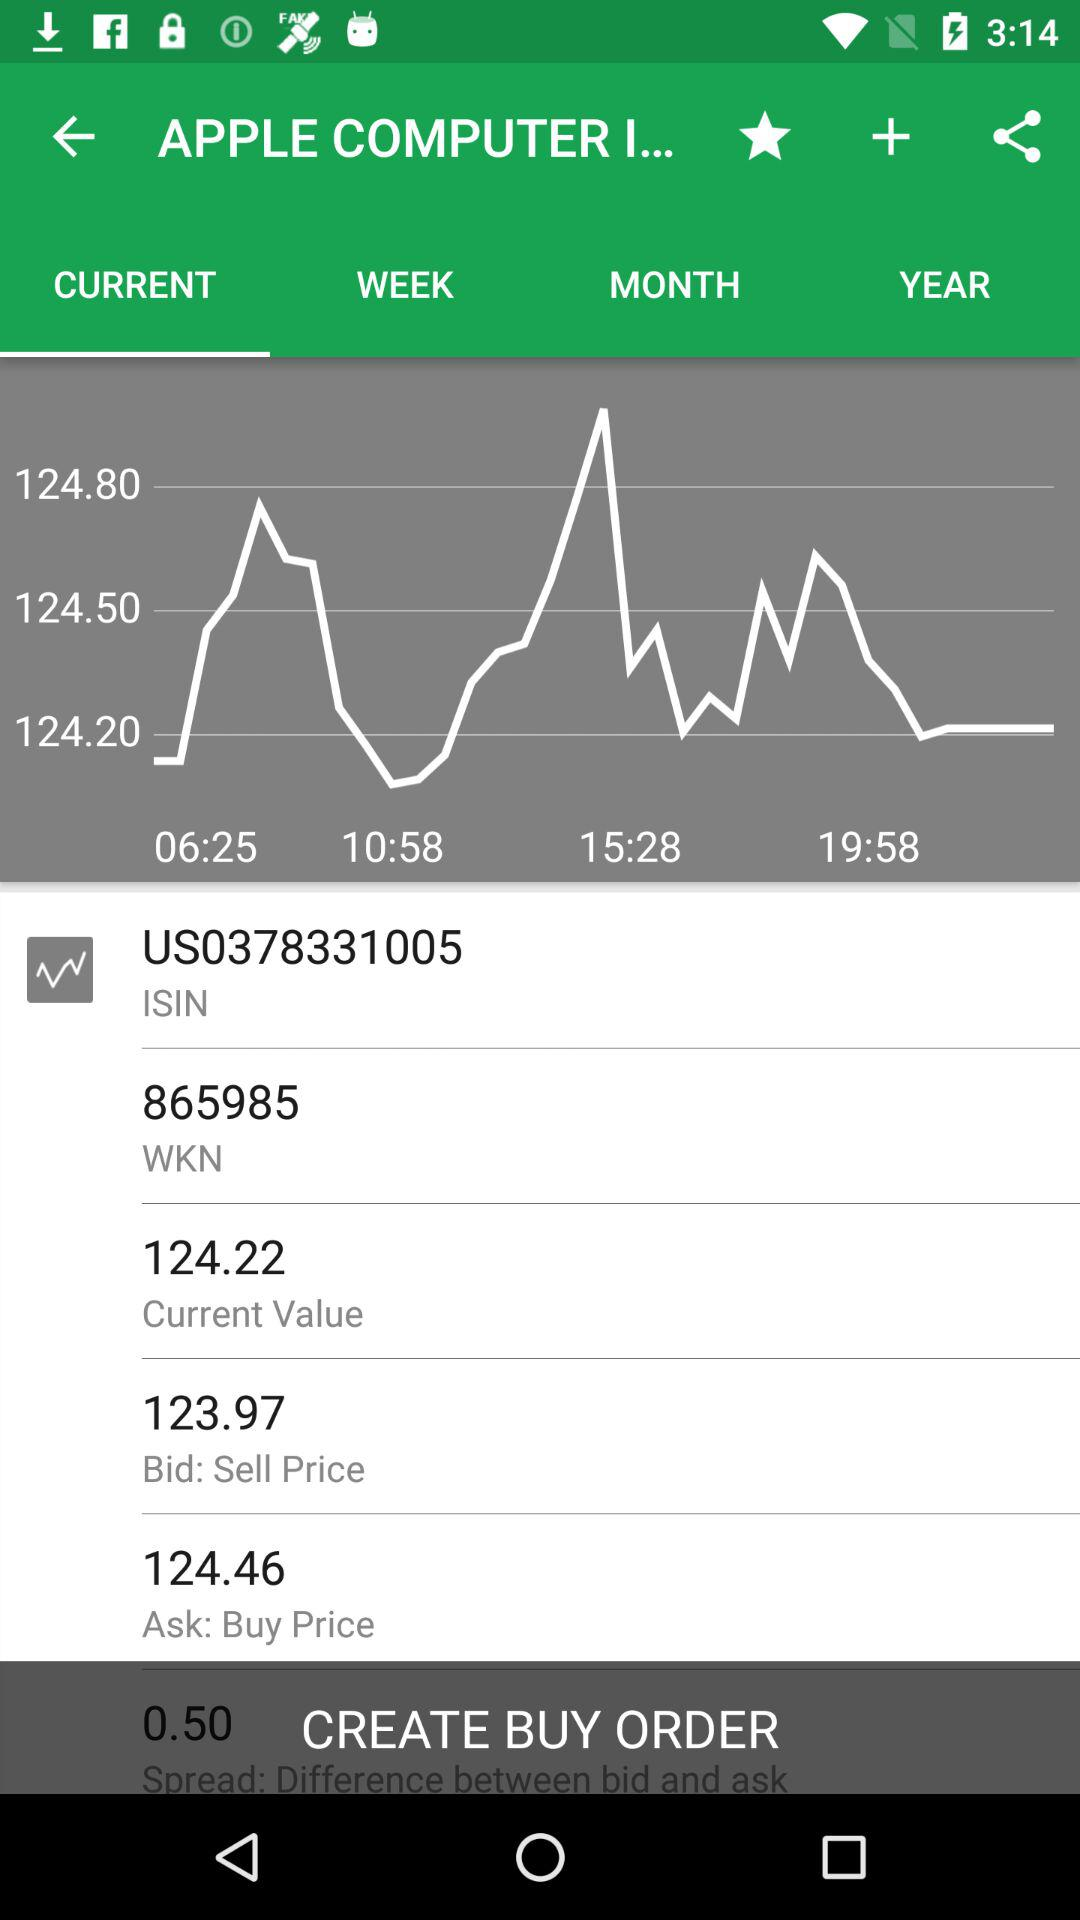What is the "Ask: Buy Price"? The "Ask: Buy Price" is 124.46. 